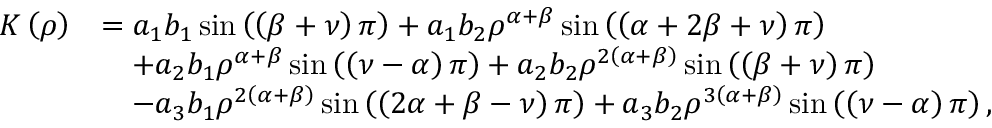Convert formula to latex. <formula><loc_0><loc_0><loc_500><loc_500>\begin{array} { r l } { K \left ( \rho \right ) } & { = a _ { 1 } b _ { 1 } \sin \left ( \left ( \beta + \nu \right ) \pi \right ) + a _ { 1 } b _ { 2 } \rho ^ { \alpha + \beta } \sin \left ( \left ( \alpha + 2 \beta + \nu \right ) \pi \right ) } \\ & { \quad + a _ { 2 } b _ { 1 } \rho ^ { \alpha + \beta } \sin \left ( \left ( \nu - \alpha \right ) \pi \right ) + a _ { 2 } b _ { 2 } \rho ^ { 2 \left ( \alpha + \beta \right ) } \sin \left ( \left ( \beta + \nu \right ) \pi \right ) } \\ & { \quad - a _ { 3 } b _ { 1 } \rho ^ { 2 \left ( \alpha + \beta \right ) } \sin \left ( \left ( 2 \alpha + \beta - \nu \right ) \pi \right ) + a _ { 3 } b _ { 2 } \rho ^ { 3 \left ( \alpha + \beta \right ) } \sin \left ( \left ( \nu - \alpha \right ) \pi \right ) , } \end{array}</formula> 